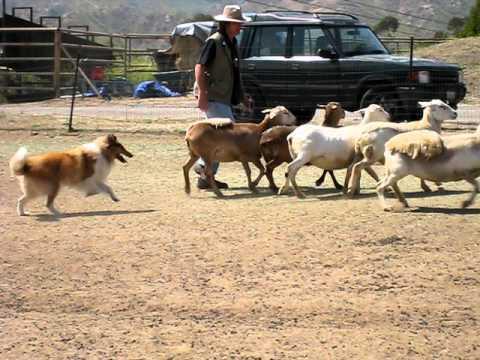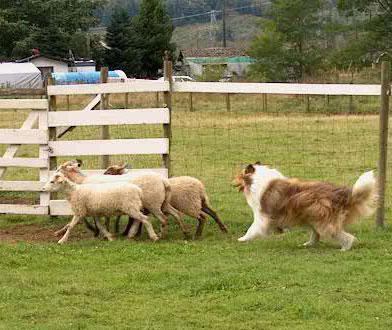The first image is the image on the left, the second image is the image on the right. Assess this claim about the two images: "An image shows a dog behind three sheep which are moving leftward.". Correct or not? Answer yes or no. Yes. 